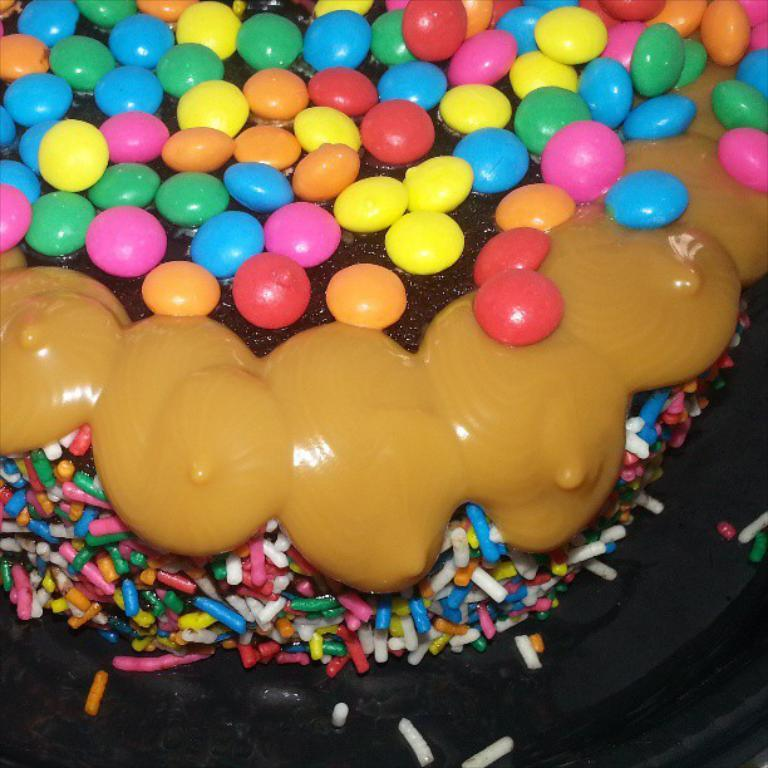What is the main subject of the image? The main subject of the image is a cake. What decorations are on the cake? There are gems at the top of the cake. What is inside the cake? There is cream in the middle of the cake. What type of plantation can be seen in the background of the image? There is no plantation visible in the image; it features a cake with gems and cream. How does the cake feel about the gems on top? The cake is an inanimate object and does not have feelings or a temper. 